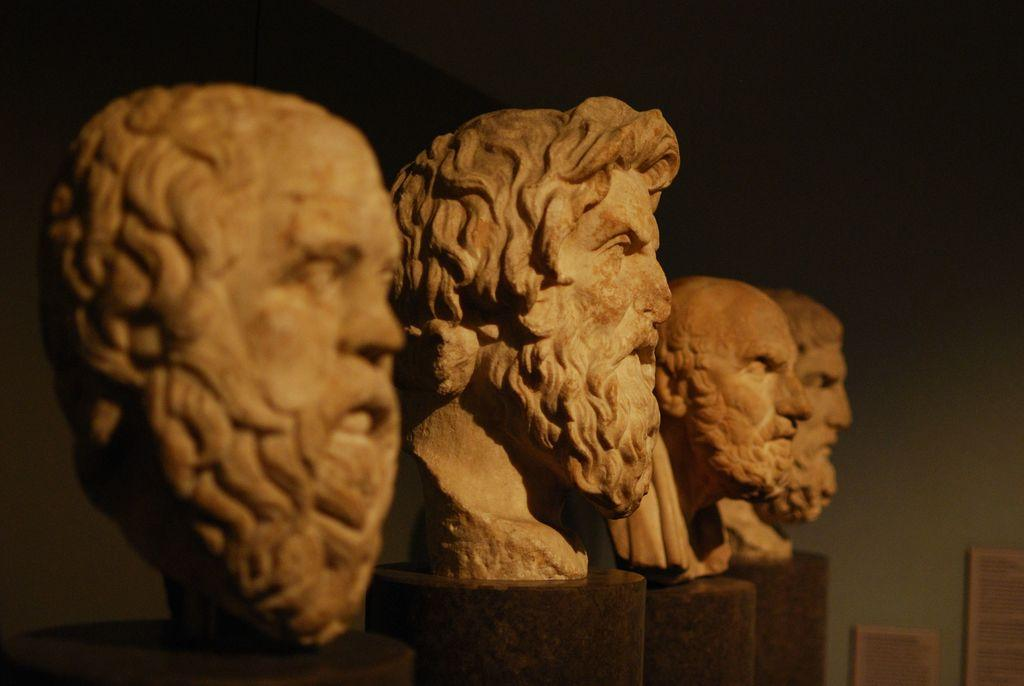What type of artwork is present in the image? There are sculptures in the image. Can you describe the background of the image? The background of the image is blurred. What is the profit made from the sculptures in the image? There is no information about profit in the image, as it only shows sculptures and a blurred background. 